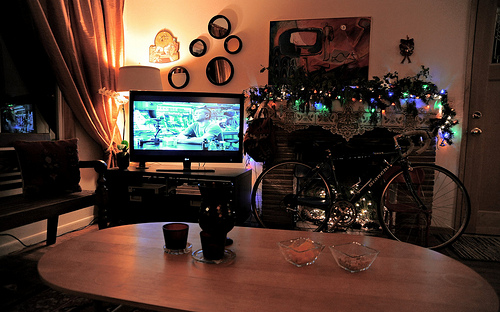<image>
Is the table in front of the bike? Yes. The table is positioned in front of the bike, appearing closer to the camera viewpoint. 